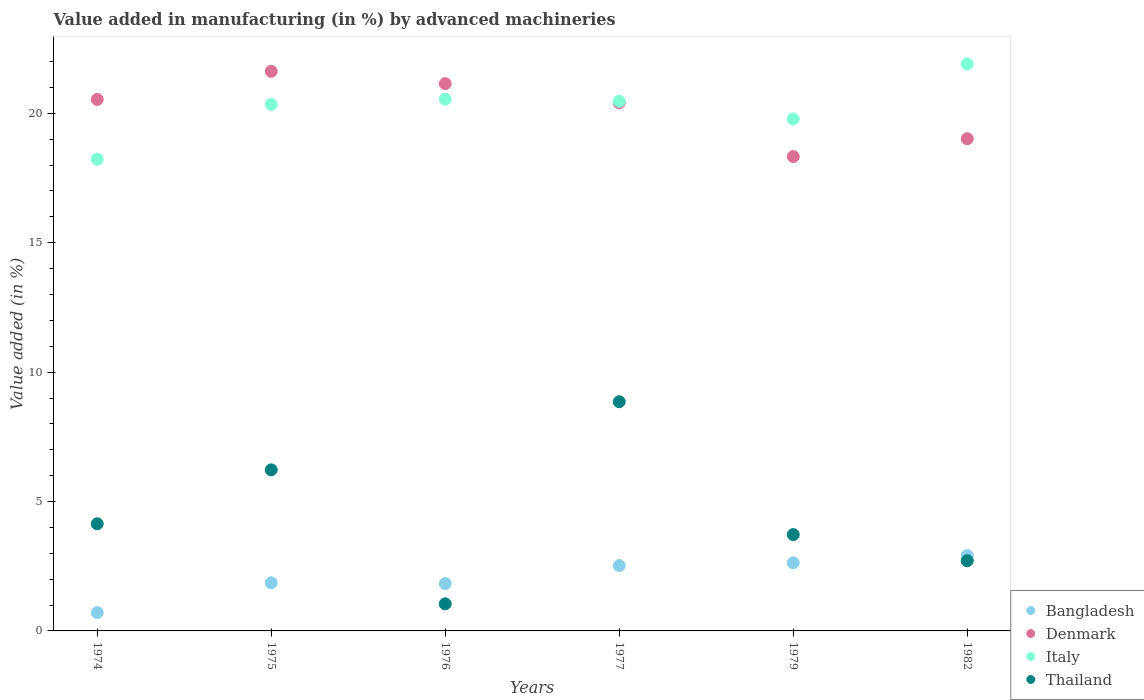How many different coloured dotlines are there?
Keep it short and to the point. 4. Is the number of dotlines equal to the number of legend labels?
Offer a terse response. Yes. What is the percentage of value added in manufacturing by advanced machineries in Thailand in 1982?
Your response must be concise. 2.71. Across all years, what is the maximum percentage of value added in manufacturing by advanced machineries in Italy?
Provide a short and direct response. 21.91. Across all years, what is the minimum percentage of value added in manufacturing by advanced machineries in Bangladesh?
Your response must be concise. 0.71. In which year was the percentage of value added in manufacturing by advanced machineries in Thailand minimum?
Provide a succinct answer. 1976. What is the total percentage of value added in manufacturing by advanced machineries in Denmark in the graph?
Ensure brevity in your answer.  121.07. What is the difference between the percentage of value added in manufacturing by advanced machineries in Bangladesh in 1979 and that in 1982?
Offer a terse response. -0.28. What is the difference between the percentage of value added in manufacturing by advanced machineries in Bangladesh in 1979 and the percentage of value added in manufacturing by advanced machineries in Denmark in 1974?
Offer a very short reply. -17.91. What is the average percentage of value added in manufacturing by advanced machineries in Thailand per year?
Make the answer very short. 4.45. In the year 1977, what is the difference between the percentage of value added in manufacturing by advanced machineries in Thailand and percentage of value added in manufacturing by advanced machineries in Bangladesh?
Your response must be concise. 6.33. What is the ratio of the percentage of value added in manufacturing by advanced machineries in Thailand in 1974 to that in 1982?
Give a very brief answer. 1.53. Is the percentage of value added in manufacturing by advanced machineries in Italy in 1974 less than that in 1976?
Make the answer very short. Yes. Is the difference between the percentage of value added in manufacturing by advanced machineries in Thailand in 1975 and 1976 greater than the difference between the percentage of value added in manufacturing by advanced machineries in Bangladesh in 1975 and 1976?
Your response must be concise. Yes. What is the difference between the highest and the second highest percentage of value added in manufacturing by advanced machineries in Denmark?
Offer a terse response. 0.48. What is the difference between the highest and the lowest percentage of value added in manufacturing by advanced machineries in Bangladesh?
Give a very brief answer. 2.2. Is it the case that in every year, the sum of the percentage of value added in manufacturing by advanced machineries in Denmark and percentage of value added in manufacturing by advanced machineries in Bangladesh  is greater than the sum of percentage of value added in manufacturing by advanced machineries in Italy and percentage of value added in manufacturing by advanced machineries in Thailand?
Keep it short and to the point. Yes. Is the percentage of value added in manufacturing by advanced machineries in Bangladesh strictly less than the percentage of value added in manufacturing by advanced machineries in Thailand over the years?
Your answer should be very brief. No. What is the difference between two consecutive major ticks on the Y-axis?
Offer a very short reply. 5. Does the graph contain grids?
Make the answer very short. No. What is the title of the graph?
Your answer should be compact. Value added in manufacturing (in %) by advanced machineries. What is the label or title of the Y-axis?
Ensure brevity in your answer.  Value added (in %). What is the Value added (in %) of Bangladesh in 1974?
Provide a succinct answer. 0.71. What is the Value added (in %) in Denmark in 1974?
Provide a short and direct response. 20.54. What is the Value added (in %) of Italy in 1974?
Your answer should be very brief. 18.23. What is the Value added (in %) of Thailand in 1974?
Offer a very short reply. 4.14. What is the Value added (in %) in Bangladesh in 1975?
Your response must be concise. 1.86. What is the Value added (in %) of Denmark in 1975?
Provide a short and direct response. 21.62. What is the Value added (in %) of Italy in 1975?
Your answer should be compact. 20.34. What is the Value added (in %) in Thailand in 1975?
Make the answer very short. 6.22. What is the Value added (in %) of Bangladesh in 1976?
Keep it short and to the point. 1.83. What is the Value added (in %) in Denmark in 1976?
Offer a very short reply. 21.15. What is the Value added (in %) of Italy in 1976?
Your response must be concise. 20.55. What is the Value added (in %) in Thailand in 1976?
Keep it short and to the point. 1.05. What is the Value added (in %) of Bangladesh in 1977?
Provide a succinct answer. 2.52. What is the Value added (in %) in Denmark in 1977?
Provide a succinct answer. 20.41. What is the Value added (in %) in Italy in 1977?
Offer a terse response. 20.47. What is the Value added (in %) of Thailand in 1977?
Provide a short and direct response. 8.86. What is the Value added (in %) of Bangladesh in 1979?
Your answer should be very brief. 2.63. What is the Value added (in %) of Denmark in 1979?
Your response must be concise. 18.33. What is the Value added (in %) in Italy in 1979?
Your answer should be very brief. 19.79. What is the Value added (in %) of Thailand in 1979?
Ensure brevity in your answer.  3.72. What is the Value added (in %) in Bangladesh in 1982?
Make the answer very short. 2.91. What is the Value added (in %) in Denmark in 1982?
Your response must be concise. 19.02. What is the Value added (in %) in Italy in 1982?
Provide a succinct answer. 21.91. What is the Value added (in %) of Thailand in 1982?
Provide a short and direct response. 2.71. Across all years, what is the maximum Value added (in %) of Bangladesh?
Your answer should be very brief. 2.91. Across all years, what is the maximum Value added (in %) of Denmark?
Ensure brevity in your answer.  21.62. Across all years, what is the maximum Value added (in %) in Italy?
Make the answer very short. 21.91. Across all years, what is the maximum Value added (in %) in Thailand?
Offer a terse response. 8.86. Across all years, what is the minimum Value added (in %) of Bangladesh?
Ensure brevity in your answer.  0.71. Across all years, what is the minimum Value added (in %) of Denmark?
Keep it short and to the point. 18.33. Across all years, what is the minimum Value added (in %) in Italy?
Your answer should be very brief. 18.23. Across all years, what is the minimum Value added (in %) in Thailand?
Your answer should be very brief. 1.05. What is the total Value added (in %) of Bangladesh in the graph?
Give a very brief answer. 12.46. What is the total Value added (in %) of Denmark in the graph?
Give a very brief answer. 121.07. What is the total Value added (in %) of Italy in the graph?
Your response must be concise. 121.28. What is the total Value added (in %) of Thailand in the graph?
Provide a succinct answer. 26.7. What is the difference between the Value added (in %) in Bangladesh in 1974 and that in 1975?
Provide a succinct answer. -1.15. What is the difference between the Value added (in %) in Denmark in 1974 and that in 1975?
Offer a very short reply. -1.09. What is the difference between the Value added (in %) of Italy in 1974 and that in 1975?
Make the answer very short. -2.12. What is the difference between the Value added (in %) of Thailand in 1974 and that in 1975?
Ensure brevity in your answer.  -2.08. What is the difference between the Value added (in %) of Bangladesh in 1974 and that in 1976?
Provide a succinct answer. -1.12. What is the difference between the Value added (in %) in Denmark in 1974 and that in 1976?
Provide a short and direct response. -0.61. What is the difference between the Value added (in %) in Italy in 1974 and that in 1976?
Your answer should be very brief. -2.32. What is the difference between the Value added (in %) of Thailand in 1974 and that in 1976?
Offer a terse response. 3.09. What is the difference between the Value added (in %) in Bangladesh in 1974 and that in 1977?
Your answer should be compact. -1.82. What is the difference between the Value added (in %) in Denmark in 1974 and that in 1977?
Give a very brief answer. 0.13. What is the difference between the Value added (in %) of Italy in 1974 and that in 1977?
Your response must be concise. -2.24. What is the difference between the Value added (in %) of Thailand in 1974 and that in 1977?
Make the answer very short. -4.72. What is the difference between the Value added (in %) of Bangladesh in 1974 and that in 1979?
Make the answer very short. -1.92. What is the difference between the Value added (in %) of Denmark in 1974 and that in 1979?
Offer a very short reply. 2.21. What is the difference between the Value added (in %) in Italy in 1974 and that in 1979?
Ensure brevity in your answer.  -1.56. What is the difference between the Value added (in %) of Thailand in 1974 and that in 1979?
Offer a very short reply. 0.42. What is the difference between the Value added (in %) in Bangladesh in 1974 and that in 1982?
Give a very brief answer. -2.2. What is the difference between the Value added (in %) of Denmark in 1974 and that in 1982?
Give a very brief answer. 1.52. What is the difference between the Value added (in %) in Italy in 1974 and that in 1982?
Give a very brief answer. -3.68. What is the difference between the Value added (in %) in Thailand in 1974 and that in 1982?
Provide a short and direct response. 1.43. What is the difference between the Value added (in %) of Bangladesh in 1975 and that in 1976?
Keep it short and to the point. 0.03. What is the difference between the Value added (in %) in Denmark in 1975 and that in 1976?
Offer a terse response. 0.48. What is the difference between the Value added (in %) in Italy in 1975 and that in 1976?
Provide a succinct answer. -0.2. What is the difference between the Value added (in %) in Thailand in 1975 and that in 1976?
Provide a short and direct response. 5.18. What is the difference between the Value added (in %) in Bangladesh in 1975 and that in 1977?
Offer a terse response. -0.66. What is the difference between the Value added (in %) of Denmark in 1975 and that in 1977?
Offer a very short reply. 1.22. What is the difference between the Value added (in %) of Italy in 1975 and that in 1977?
Your response must be concise. -0.12. What is the difference between the Value added (in %) of Thailand in 1975 and that in 1977?
Ensure brevity in your answer.  -2.63. What is the difference between the Value added (in %) of Bangladesh in 1975 and that in 1979?
Ensure brevity in your answer.  -0.77. What is the difference between the Value added (in %) in Denmark in 1975 and that in 1979?
Give a very brief answer. 3.29. What is the difference between the Value added (in %) of Italy in 1975 and that in 1979?
Offer a terse response. 0.56. What is the difference between the Value added (in %) in Thailand in 1975 and that in 1979?
Offer a very short reply. 2.5. What is the difference between the Value added (in %) of Bangladesh in 1975 and that in 1982?
Ensure brevity in your answer.  -1.05. What is the difference between the Value added (in %) in Denmark in 1975 and that in 1982?
Ensure brevity in your answer.  2.6. What is the difference between the Value added (in %) in Italy in 1975 and that in 1982?
Offer a very short reply. -1.56. What is the difference between the Value added (in %) in Thailand in 1975 and that in 1982?
Provide a short and direct response. 3.51. What is the difference between the Value added (in %) of Bangladesh in 1976 and that in 1977?
Provide a succinct answer. -0.7. What is the difference between the Value added (in %) in Denmark in 1976 and that in 1977?
Make the answer very short. 0.74. What is the difference between the Value added (in %) of Italy in 1976 and that in 1977?
Your response must be concise. 0.08. What is the difference between the Value added (in %) in Thailand in 1976 and that in 1977?
Offer a very short reply. -7.81. What is the difference between the Value added (in %) of Bangladesh in 1976 and that in 1979?
Provide a short and direct response. -0.8. What is the difference between the Value added (in %) of Denmark in 1976 and that in 1979?
Keep it short and to the point. 2.82. What is the difference between the Value added (in %) in Italy in 1976 and that in 1979?
Offer a terse response. 0.76. What is the difference between the Value added (in %) of Thailand in 1976 and that in 1979?
Your answer should be very brief. -2.68. What is the difference between the Value added (in %) of Bangladesh in 1976 and that in 1982?
Give a very brief answer. -1.08. What is the difference between the Value added (in %) of Denmark in 1976 and that in 1982?
Provide a short and direct response. 2.13. What is the difference between the Value added (in %) of Italy in 1976 and that in 1982?
Offer a terse response. -1.36. What is the difference between the Value added (in %) of Thailand in 1976 and that in 1982?
Offer a terse response. -1.67. What is the difference between the Value added (in %) in Bangladesh in 1977 and that in 1979?
Your response must be concise. -0.11. What is the difference between the Value added (in %) of Denmark in 1977 and that in 1979?
Your answer should be very brief. 2.08. What is the difference between the Value added (in %) in Italy in 1977 and that in 1979?
Provide a short and direct response. 0.68. What is the difference between the Value added (in %) in Thailand in 1977 and that in 1979?
Offer a very short reply. 5.13. What is the difference between the Value added (in %) in Bangladesh in 1977 and that in 1982?
Provide a short and direct response. -0.39. What is the difference between the Value added (in %) in Denmark in 1977 and that in 1982?
Provide a short and direct response. 1.39. What is the difference between the Value added (in %) of Italy in 1977 and that in 1982?
Your answer should be compact. -1.44. What is the difference between the Value added (in %) in Thailand in 1977 and that in 1982?
Your answer should be very brief. 6.14. What is the difference between the Value added (in %) in Bangladesh in 1979 and that in 1982?
Make the answer very short. -0.28. What is the difference between the Value added (in %) in Denmark in 1979 and that in 1982?
Make the answer very short. -0.69. What is the difference between the Value added (in %) of Italy in 1979 and that in 1982?
Your answer should be compact. -2.12. What is the difference between the Value added (in %) of Thailand in 1979 and that in 1982?
Give a very brief answer. 1.01. What is the difference between the Value added (in %) of Bangladesh in 1974 and the Value added (in %) of Denmark in 1975?
Your response must be concise. -20.92. What is the difference between the Value added (in %) in Bangladesh in 1974 and the Value added (in %) in Italy in 1975?
Provide a succinct answer. -19.64. What is the difference between the Value added (in %) of Bangladesh in 1974 and the Value added (in %) of Thailand in 1975?
Keep it short and to the point. -5.52. What is the difference between the Value added (in %) in Denmark in 1974 and the Value added (in %) in Italy in 1975?
Make the answer very short. 0.19. What is the difference between the Value added (in %) of Denmark in 1974 and the Value added (in %) of Thailand in 1975?
Make the answer very short. 14.31. What is the difference between the Value added (in %) in Italy in 1974 and the Value added (in %) in Thailand in 1975?
Keep it short and to the point. 12. What is the difference between the Value added (in %) in Bangladesh in 1974 and the Value added (in %) in Denmark in 1976?
Offer a terse response. -20.44. What is the difference between the Value added (in %) in Bangladesh in 1974 and the Value added (in %) in Italy in 1976?
Your answer should be very brief. -19.84. What is the difference between the Value added (in %) in Bangladesh in 1974 and the Value added (in %) in Thailand in 1976?
Provide a succinct answer. -0.34. What is the difference between the Value added (in %) of Denmark in 1974 and the Value added (in %) of Italy in 1976?
Make the answer very short. -0.01. What is the difference between the Value added (in %) of Denmark in 1974 and the Value added (in %) of Thailand in 1976?
Your response must be concise. 19.49. What is the difference between the Value added (in %) of Italy in 1974 and the Value added (in %) of Thailand in 1976?
Provide a succinct answer. 17.18. What is the difference between the Value added (in %) of Bangladesh in 1974 and the Value added (in %) of Denmark in 1977?
Your answer should be compact. -19.7. What is the difference between the Value added (in %) in Bangladesh in 1974 and the Value added (in %) in Italy in 1977?
Keep it short and to the point. -19.76. What is the difference between the Value added (in %) in Bangladesh in 1974 and the Value added (in %) in Thailand in 1977?
Make the answer very short. -8.15. What is the difference between the Value added (in %) in Denmark in 1974 and the Value added (in %) in Italy in 1977?
Provide a short and direct response. 0.07. What is the difference between the Value added (in %) of Denmark in 1974 and the Value added (in %) of Thailand in 1977?
Offer a very short reply. 11.68. What is the difference between the Value added (in %) of Italy in 1974 and the Value added (in %) of Thailand in 1977?
Ensure brevity in your answer.  9.37. What is the difference between the Value added (in %) of Bangladesh in 1974 and the Value added (in %) of Denmark in 1979?
Offer a terse response. -17.62. What is the difference between the Value added (in %) in Bangladesh in 1974 and the Value added (in %) in Italy in 1979?
Make the answer very short. -19.08. What is the difference between the Value added (in %) in Bangladesh in 1974 and the Value added (in %) in Thailand in 1979?
Offer a very short reply. -3.02. What is the difference between the Value added (in %) in Denmark in 1974 and the Value added (in %) in Italy in 1979?
Provide a short and direct response. 0.75. What is the difference between the Value added (in %) of Denmark in 1974 and the Value added (in %) of Thailand in 1979?
Provide a succinct answer. 16.82. What is the difference between the Value added (in %) of Italy in 1974 and the Value added (in %) of Thailand in 1979?
Keep it short and to the point. 14.5. What is the difference between the Value added (in %) in Bangladesh in 1974 and the Value added (in %) in Denmark in 1982?
Your answer should be compact. -18.31. What is the difference between the Value added (in %) in Bangladesh in 1974 and the Value added (in %) in Italy in 1982?
Give a very brief answer. -21.2. What is the difference between the Value added (in %) of Bangladesh in 1974 and the Value added (in %) of Thailand in 1982?
Your answer should be compact. -2. What is the difference between the Value added (in %) of Denmark in 1974 and the Value added (in %) of Italy in 1982?
Keep it short and to the point. -1.37. What is the difference between the Value added (in %) in Denmark in 1974 and the Value added (in %) in Thailand in 1982?
Give a very brief answer. 17.83. What is the difference between the Value added (in %) of Italy in 1974 and the Value added (in %) of Thailand in 1982?
Keep it short and to the point. 15.51. What is the difference between the Value added (in %) in Bangladesh in 1975 and the Value added (in %) in Denmark in 1976?
Your response must be concise. -19.29. What is the difference between the Value added (in %) in Bangladesh in 1975 and the Value added (in %) in Italy in 1976?
Your answer should be very brief. -18.69. What is the difference between the Value added (in %) of Bangladesh in 1975 and the Value added (in %) of Thailand in 1976?
Keep it short and to the point. 0.81. What is the difference between the Value added (in %) in Denmark in 1975 and the Value added (in %) in Italy in 1976?
Your response must be concise. 1.08. What is the difference between the Value added (in %) of Denmark in 1975 and the Value added (in %) of Thailand in 1976?
Make the answer very short. 20.58. What is the difference between the Value added (in %) in Italy in 1975 and the Value added (in %) in Thailand in 1976?
Ensure brevity in your answer.  19.3. What is the difference between the Value added (in %) of Bangladesh in 1975 and the Value added (in %) of Denmark in 1977?
Your answer should be very brief. -18.55. What is the difference between the Value added (in %) in Bangladesh in 1975 and the Value added (in %) in Italy in 1977?
Give a very brief answer. -18.61. What is the difference between the Value added (in %) of Bangladesh in 1975 and the Value added (in %) of Thailand in 1977?
Give a very brief answer. -7. What is the difference between the Value added (in %) in Denmark in 1975 and the Value added (in %) in Italy in 1977?
Make the answer very short. 1.16. What is the difference between the Value added (in %) in Denmark in 1975 and the Value added (in %) in Thailand in 1977?
Give a very brief answer. 12.77. What is the difference between the Value added (in %) in Italy in 1975 and the Value added (in %) in Thailand in 1977?
Provide a short and direct response. 11.49. What is the difference between the Value added (in %) in Bangladesh in 1975 and the Value added (in %) in Denmark in 1979?
Provide a short and direct response. -16.47. What is the difference between the Value added (in %) in Bangladesh in 1975 and the Value added (in %) in Italy in 1979?
Give a very brief answer. -17.92. What is the difference between the Value added (in %) of Bangladesh in 1975 and the Value added (in %) of Thailand in 1979?
Keep it short and to the point. -1.86. What is the difference between the Value added (in %) of Denmark in 1975 and the Value added (in %) of Italy in 1979?
Make the answer very short. 1.84. What is the difference between the Value added (in %) of Denmark in 1975 and the Value added (in %) of Thailand in 1979?
Make the answer very short. 17.9. What is the difference between the Value added (in %) of Italy in 1975 and the Value added (in %) of Thailand in 1979?
Your response must be concise. 16.62. What is the difference between the Value added (in %) of Bangladesh in 1975 and the Value added (in %) of Denmark in 1982?
Keep it short and to the point. -17.16. What is the difference between the Value added (in %) of Bangladesh in 1975 and the Value added (in %) of Italy in 1982?
Ensure brevity in your answer.  -20.05. What is the difference between the Value added (in %) of Bangladesh in 1975 and the Value added (in %) of Thailand in 1982?
Provide a succinct answer. -0.85. What is the difference between the Value added (in %) of Denmark in 1975 and the Value added (in %) of Italy in 1982?
Make the answer very short. -0.28. What is the difference between the Value added (in %) in Denmark in 1975 and the Value added (in %) in Thailand in 1982?
Your response must be concise. 18.91. What is the difference between the Value added (in %) in Italy in 1975 and the Value added (in %) in Thailand in 1982?
Ensure brevity in your answer.  17.63. What is the difference between the Value added (in %) in Bangladesh in 1976 and the Value added (in %) in Denmark in 1977?
Provide a succinct answer. -18.58. What is the difference between the Value added (in %) of Bangladesh in 1976 and the Value added (in %) of Italy in 1977?
Provide a short and direct response. -18.64. What is the difference between the Value added (in %) in Bangladesh in 1976 and the Value added (in %) in Thailand in 1977?
Your answer should be compact. -7.03. What is the difference between the Value added (in %) in Denmark in 1976 and the Value added (in %) in Italy in 1977?
Provide a succinct answer. 0.68. What is the difference between the Value added (in %) in Denmark in 1976 and the Value added (in %) in Thailand in 1977?
Give a very brief answer. 12.29. What is the difference between the Value added (in %) of Italy in 1976 and the Value added (in %) of Thailand in 1977?
Your answer should be very brief. 11.69. What is the difference between the Value added (in %) in Bangladesh in 1976 and the Value added (in %) in Denmark in 1979?
Provide a succinct answer. -16.5. What is the difference between the Value added (in %) in Bangladesh in 1976 and the Value added (in %) in Italy in 1979?
Your answer should be very brief. -17.96. What is the difference between the Value added (in %) in Bangladesh in 1976 and the Value added (in %) in Thailand in 1979?
Your answer should be very brief. -1.89. What is the difference between the Value added (in %) in Denmark in 1976 and the Value added (in %) in Italy in 1979?
Provide a short and direct response. 1.36. What is the difference between the Value added (in %) in Denmark in 1976 and the Value added (in %) in Thailand in 1979?
Offer a very short reply. 17.43. What is the difference between the Value added (in %) of Italy in 1976 and the Value added (in %) of Thailand in 1979?
Make the answer very short. 16.83. What is the difference between the Value added (in %) in Bangladesh in 1976 and the Value added (in %) in Denmark in 1982?
Make the answer very short. -17.19. What is the difference between the Value added (in %) in Bangladesh in 1976 and the Value added (in %) in Italy in 1982?
Ensure brevity in your answer.  -20.08. What is the difference between the Value added (in %) in Bangladesh in 1976 and the Value added (in %) in Thailand in 1982?
Offer a terse response. -0.88. What is the difference between the Value added (in %) in Denmark in 1976 and the Value added (in %) in Italy in 1982?
Your answer should be very brief. -0.76. What is the difference between the Value added (in %) of Denmark in 1976 and the Value added (in %) of Thailand in 1982?
Offer a terse response. 18.44. What is the difference between the Value added (in %) in Italy in 1976 and the Value added (in %) in Thailand in 1982?
Your answer should be very brief. 17.84. What is the difference between the Value added (in %) of Bangladesh in 1977 and the Value added (in %) of Denmark in 1979?
Provide a succinct answer. -15.81. What is the difference between the Value added (in %) of Bangladesh in 1977 and the Value added (in %) of Italy in 1979?
Your response must be concise. -17.26. What is the difference between the Value added (in %) of Bangladesh in 1977 and the Value added (in %) of Thailand in 1979?
Offer a terse response. -1.2. What is the difference between the Value added (in %) of Denmark in 1977 and the Value added (in %) of Italy in 1979?
Offer a terse response. 0.62. What is the difference between the Value added (in %) of Denmark in 1977 and the Value added (in %) of Thailand in 1979?
Offer a very short reply. 16.69. What is the difference between the Value added (in %) in Italy in 1977 and the Value added (in %) in Thailand in 1979?
Give a very brief answer. 16.74. What is the difference between the Value added (in %) of Bangladesh in 1977 and the Value added (in %) of Denmark in 1982?
Provide a succinct answer. -16.5. What is the difference between the Value added (in %) in Bangladesh in 1977 and the Value added (in %) in Italy in 1982?
Your answer should be very brief. -19.38. What is the difference between the Value added (in %) of Bangladesh in 1977 and the Value added (in %) of Thailand in 1982?
Your answer should be very brief. -0.19. What is the difference between the Value added (in %) of Denmark in 1977 and the Value added (in %) of Italy in 1982?
Your response must be concise. -1.5. What is the difference between the Value added (in %) of Denmark in 1977 and the Value added (in %) of Thailand in 1982?
Your answer should be very brief. 17.7. What is the difference between the Value added (in %) in Italy in 1977 and the Value added (in %) in Thailand in 1982?
Provide a succinct answer. 17.75. What is the difference between the Value added (in %) in Bangladesh in 1979 and the Value added (in %) in Denmark in 1982?
Ensure brevity in your answer.  -16.39. What is the difference between the Value added (in %) of Bangladesh in 1979 and the Value added (in %) of Italy in 1982?
Your answer should be very brief. -19.27. What is the difference between the Value added (in %) in Bangladesh in 1979 and the Value added (in %) in Thailand in 1982?
Offer a terse response. -0.08. What is the difference between the Value added (in %) of Denmark in 1979 and the Value added (in %) of Italy in 1982?
Your answer should be very brief. -3.58. What is the difference between the Value added (in %) of Denmark in 1979 and the Value added (in %) of Thailand in 1982?
Make the answer very short. 15.62. What is the difference between the Value added (in %) of Italy in 1979 and the Value added (in %) of Thailand in 1982?
Ensure brevity in your answer.  17.07. What is the average Value added (in %) of Bangladesh per year?
Give a very brief answer. 2.08. What is the average Value added (in %) in Denmark per year?
Provide a short and direct response. 20.18. What is the average Value added (in %) of Italy per year?
Your answer should be compact. 20.21. What is the average Value added (in %) of Thailand per year?
Offer a terse response. 4.45. In the year 1974, what is the difference between the Value added (in %) of Bangladesh and Value added (in %) of Denmark?
Offer a very short reply. -19.83. In the year 1974, what is the difference between the Value added (in %) of Bangladesh and Value added (in %) of Italy?
Keep it short and to the point. -17.52. In the year 1974, what is the difference between the Value added (in %) of Bangladesh and Value added (in %) of Thailand?
Your response must be concise. -3.43. In the year 1974, what is the difference between the Value added (in %) in Denmark and Value added (in %) in Italy?
Your answer should be compact. 2.31. In the year 1974, what is the difference between the Value added (in %) of Denmark and Value added (in %) of Thailand?
Keep it short and to the point. 16.4. In the year 1974, what is the difference between the Value added (in %) in Italy and Value added (in %) in Thailand?
Your response must be concise. 14.09. In the year 1975, what is the difference between the Value added (in %) of Bangladesh and Value added (in %) of Denmark?
Ensure brevity in your answer.  -19.76. In the year 1975, what is the difference between the Value added (in %) in Bangladesh and Value added (in %) in Italy?
Provide a succinct answer. -18.48. In the year 1975, what is the difference between the Value added (in %) of Bangladesh and Value added (in %) of Thailand?
Provide a succinct answer. -4.36. In the year 1975, what is the difference between the Value added (in %) in Denmark and Value added (in %) in Italy?
Keep it short and to the point. 1.28. In the year 1975, what is the difference between the Value added (in %) of Denmark and Value added (in %) of Thailand?
Keep it short and to the point. 15.4. In the year 1975, what is the difference between the Value added (in %) in Italy and Value added (in %) in Thailand?
Ensure brevity in your answer.  14.12. In the year 1976, what is the difference between the Value added (in %) in Bangladesh and Value added (in %) in Denmark?
Make the answer very short. -19.32. In the year 1976, what is the difference between the Value added (in %) in Bangladesh and Value added (in %) in Italy?
Ensure brevity in your answer.  -18.72. In the year 1976, what is the difference between the Value added (in %) in Bangladesh and Value added (in %) in Thailand?
Your response must be concise. 0.78. In the year 1976, what is the difference between the Value added (in %) in Denmark and Value added (in %) in Italy?
Ensure brevity in your answer.  0.6. In the year 1976, what is the difference between the Value added (in %) in Denmark and Value added (in %) in Thailand?
Provide a short and direct response. 20.1. In the year 1976, what is the difference between the Value added (in %) of Italy and Value added (in %) of Thailand?
Keep it short and to the point. 19.5. In the year 1977, what is the difference between the Value added (in %) of Bangladesh and Value added (in %) of Denmark?
Give a very brief answer. -17.88. In the year 1977, what is the difference between the Value added (in %) in Bangladesh and Value added (in %) in Italy?
Your response must be concise. -17.94. In the year 1977, what is the difference between the Value added (in %) in Bangladesh and Value added (in %) in Thailand?
Your response must be concise. -6.33. In the year 1977, what is the difference between the Value added (in %) in Denmark and Value added (in %) in Italy?
Your answer should be compact. -0.06. In the year 1977, what is the difference between the Value added (in %) of Denmark and Value added (in %) of Thailand?
Ensure brevity in your answer.  11.55. In the year 1977, what is the difference between the Value added (in %) in Italy and Value added (in %) in Thailand?
Ensure brevity in your answer.  11.61. In the year 1979, what is the difference between the Value added (in %) of Bangladesh and Value added (in %) of Denmark?
Your response must be concise. -15.7. In the year 1979, what is the difference between the Value added (in %) of Bangladesh and Value added (in %) of Italy?
Your response must be concise. -17.15. In the year 1979, what is the difference between the Value added (in %) of Bangladesh and Value added (in %) of Thailand?
Provide a short and direct response. -1.09. In the year 1979, what is the difference between the Value added (in %) of Denmark and Value added (in %) of Italy?
Your response must be concise. -1.45. In the year 1979, what is the difference between the Value added (in %) of Denmark and Value added (in %) of Thailand?
Your answer should be very brief. 14.61. In the year 1979, what is the difference between the Value added (in %) of Italy and Value added (in %) of Thailand?
Your answer should be very brief. 16.06. In the year 1982, what is the difference between the Value added (in %) of Bangladesh and Value added (in %) of Denmark?
Provide a short and direct response. -16.11. In the year 1982, what is the difference between the Value added (in %) of Bangladesh and Value added (in %) of Italy?
Your answer should be compact. -18.99. In the year 1982, what is the difference between the Value added (in %) of Bangladesh and Value added (in %) of Thailand?
Keep it short and to the point. 0.2. In the year 1982, what is the difference between the Value added (in %) in Denmark and Value added (in %) in Italy?
Ensure brevity in your answer.  -2.89. In the year 1982, what is the difference between the Value added (in %) of Denmark and Value added (in %) of Thailand?
Make the answer very short. 16.31. In the year 1982, what is the difference between the Value added (in %) in Italy and Value added (in %) in Thailand?
Offer a terse response. 19.19. What is the ratio of the Value added (in %) of Bangladesh in 1974 to that in 1975?
Offer a terse response. 0.38. What is the ratio of the Value added (in %) of Denmark in 1974 to that in 1975?
Provide a succinct answer. 0.95. What is the ratio of the Value added (in %) of Italy in 1974 to that in 1975?
Offer a terse response. 0.9. What is the ratio of the Value added (in %) in Thailand in 1974 to that in 1975?
Give a very brief answer. 0.67. What is the ratio of the Value added (in %) in Bangladesh in 1974 to that in 1976?
Ensure brevity in your answer.  0.39. What is the ratio of the Value added (in %) of Denmark in 1974 to that in 1976?
Your answer should be compact. 0.97. What is the ratio of the Value added (in %) of Italy in 1974 to that in 1976?
Keep it short and to the point. 0.89. What is the ratio of the Value added (in %) in Thailand in 1974 to that in 1976?
Give a very brief answer. 3.95. What is the ratio of the Value added (in %) in Bangladesh in 1974 to that in 1977?
Your answer should be very brief. 0.28. What is the ratio of the Value added (in %) in Denmark in 1974 to that in 1977?
Your answer should be very brief. 1.01. What is the ratio of the Value added (in %) in Italy in 1974 to that in 1977?
Provide a short and direct response. 0.89. What is the ratio of the Value added (in %) in Thailand in 1974 to that in 1977?
Make the answer very short. 0.47. What is the ratio of the Value added (in %) of Bangladesh in 1974 to that in 1979?
Keep it short and to the point. 0.27. What is the ratio of the Value added (in %) in Denmark in 1974 to that in 1979?
Provide a short and direct response. 1.12. What is the ratio of the Value added (in %) in Italy in 1974 to that in 1979?
Give a very brief answer. 0.92. What is the ratio of the Value added (in %) of Thailand in 1974 to that in 1979?
Ensure brevity in your answer.  1.11. What is the ratio of the Value added (in %) in Bangladesh in 1974 to that in 1982?
Offer a very short reply. 0.24. What is the ratio of the Value added (in %) of Denmark in 1974 to that in 1982?
Provide a short and direct response. 1.08. What is the ratio of the Value added (in %) in Italy in 1974 to that in 1982?
Keep it short and to the point. 0.83. What is the ratio of the Value added (in %) in Thailand in 1974 to that in 1982?
Offer a terse response. 1.53. What is the ratio of the Value added (in %) of Bangladesh in 1975 to that in 1976?
Offer a very short reply. 1.02. What is the ratio of the Value added (in %) of Denmark in 1975 to that in 1976?
Ensure brevity in your answer.  1.02. What is the ratio of the Value added (in %) of Thailand in 1975 to that in 1976?
Ensure brevity in your answer.  5.94. What is the ratio of the Value added (in %) of Bangladesh in 1975 to that in 1977?
Offer a very short reply. 0.74. What is the ratio of the Value added (in %) in Denmark in 1975 to that in 1977?
Offer a very short reply. 1.06. What is the ratio of the Value added (in %) in Italy in 1975 to that in 1977?
Your response must be concise. 0.99. What is the ratio of the Value added (in %) in Thailand in 1975 to that in 1977?
Offer a terse response. 0.7. What is the ratio of the Value added (in %) in Bangladesh in 1975 to that in 1979?
Your answer should be very brief. 0.71. What is the ratio of the Value added (in %) in Denmark in 1975 to that in 1979?
Ensure brevity in your answer.  1.18. What is the ratio of the Value added (in %) of Italy in 1975 to that in 1979?
Your answer should be compact. 1.03. What is the ratio of the Value added (in %) of Thailand in 1975 to that in 1979?
Make the answer very short. 1.67. What is the ratio of the Value added (in %) in Bangladesh in 1975 to that in 1982?
Provide a succinct answer. 0.64. What is the ratio of the Value added (in %) in Denmark in 1975 to that in 1982?
Give a very brief answer. 1.14. What is the ratio of the Value added (in %) of Italy in 1975 to that in 1982?
Make the answer very short. 0.93. What is the ratio of the Value added (in %) in Thailand in 1975 to that in 1982?
Give a very brief answer. 2.29. What is the ratio of the Value added (in %) in Bangladesh in 1976 to that in 1977?
Your answer should be very brief. 0.72. What is the ratio of the Value added (in %) in Denmark in 1976 to that in 1977?
Your answer should be very brief. 1.04. What is the ratio of the Value added (in %) of Italy in 1976 to that in 1977?
Your answer should be compact. 1. What is the ratio of the Value added (in %) in Thailand in 1976 to that in 1977?
Offer a very short reply. 0.12. What is the ratio of the Value added (in %) of Bangladesh in 1976 to that in 1979?
Provide a succinct answer. 0.69. What is the ratio of the Value added (in %) in Denmark in 1976 to that in 1979?
Provide a short and direct response. 1.15. What is the ratio of the Value added (in %) in Italy in 1976 to that in 1979?
Your response must be concise. 1.04. What is the ratio of the Value added (in %) in Thailand in 1976 to that in 1979?
Keep it short and to the point. 0.28. What is the ratio of the Value added (in %) of Bangladesh in 1976 to that in 1982?
Provide a short and direct response. 0.63. What is the ratio of the Value added (in %) in Denmark in 1976 to that in 1982?
Provide a short and direct response. 1.11. What is the ratio of the Value added (in %) in Italy in 1976 to that in 1982?
Ensure brevity in your answer.  0.94. What is the ratio of the Value added (in %) of Thailand in 1976 to that in 1982?
Make the answer very short. 0.39. What is the ratio of the Value added (in %) in Bangladesh in 1977 to that in 1979?
Give a very brief answer. 0.96. What is the ratio of the Value added (in %) of Denmark in 1977 to that in 1979?
Make the answer very short. 1.11. What is the ratio of the Value added (in %) of Italy in 1977 to that in 1979?
Your answer should be very brief. 1.03. What is the ratio of the Value added (in %) of Thailand in 1977 to that in 1979?
Make the answer very short. 2.38. What is the ratio of the Value added (in %) of Bangladesh in 1977 to that in 1982?
Your answer should be very brief. 0.87. What is the ratio of the Value added (in %) of Denmark in 1977 to that in 1982?
Make the answer very short. 1.07. What is the ratio of the Value added (in %) in Italy in 1977 to that in 1982?
Your response must be concise. 0.93. What is the ratio of the Value added (in %) in Thailand in 1977 to that in 1982?
Your answer should be compact. 3.27. What is the ratio of the Value added (in %) in Bangladesh in 1979 to that in 1982?
Your response must be concise. 0.9. What is the ratio of the Value added (in %) of Denmark in 1979 to that in 1982?
Keep it short and to the point. 0.96. What is the ratio of the Value added (in %) in Italy in 1979 to that in 1982?
Provide a short and direct response. 0.9. What is the ratio of the Value added (in %) in Thailand in 1979 to that in 1982?
Keep it short and to the point. 1.37. What is the difference between the highest and the second highest Value added (in %) in Bangladesh?
Offer a very short reply. 0.28. What is the difference between the highest and the second highest Value added (in %) of Denmark?
Provide a succinct answer. 0.48. What is the difference between the highest and the second highest Value added (in %) in Italy?
Make the answer very short. 1.36. What is the difference between the highest and the second highest Value added (in %) of Thailand?
Provide a succinct answer. 2.63. What is the difference between the highest and the lowest Value added (in %) in Bangladesh?
Ensure brevity in your answer.  2.2. What is the difference between the highest and the lowest Value added (in %) in Denmark?
Your answer should be compact. 3.29. What is the difference between the highest and the lowest Value added (in %) in Italy?
Your answer should be very brief. 3.68. What is the difference between the highest and the lowest Value added (in %) of Thailand?
Offer a terse response. 7.81. 